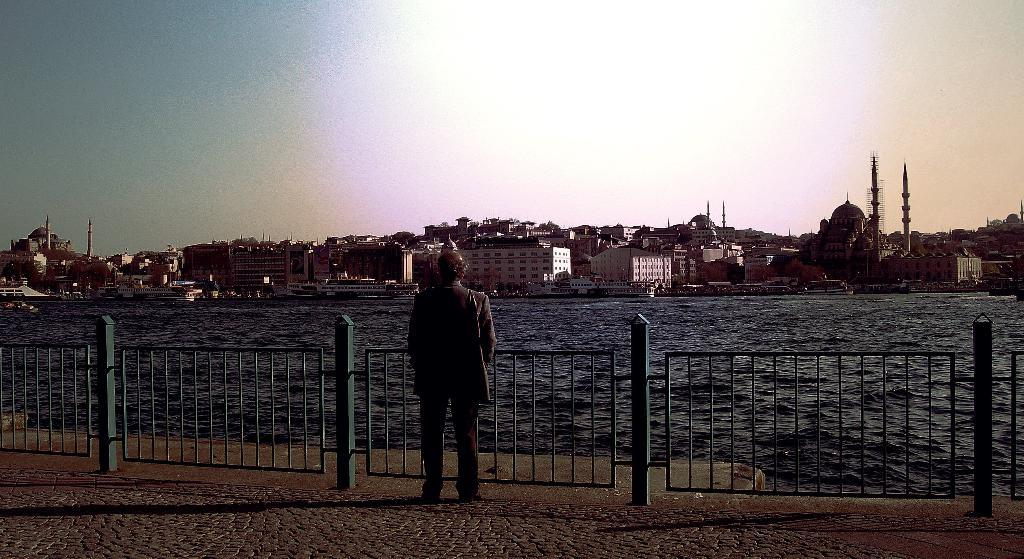What is the main subject of the image? There is a person standing in the image. Where is the person standing? The person is standing on the floor. What is located near the person? The person is beside a fence. What can be seen in the background of the image? There is water visible in the image, as well as buildings. What type of knowledge is displayed on the shelf in the image? There is no shelf present in the image, and therefore no knowledge can be displayed on it. 